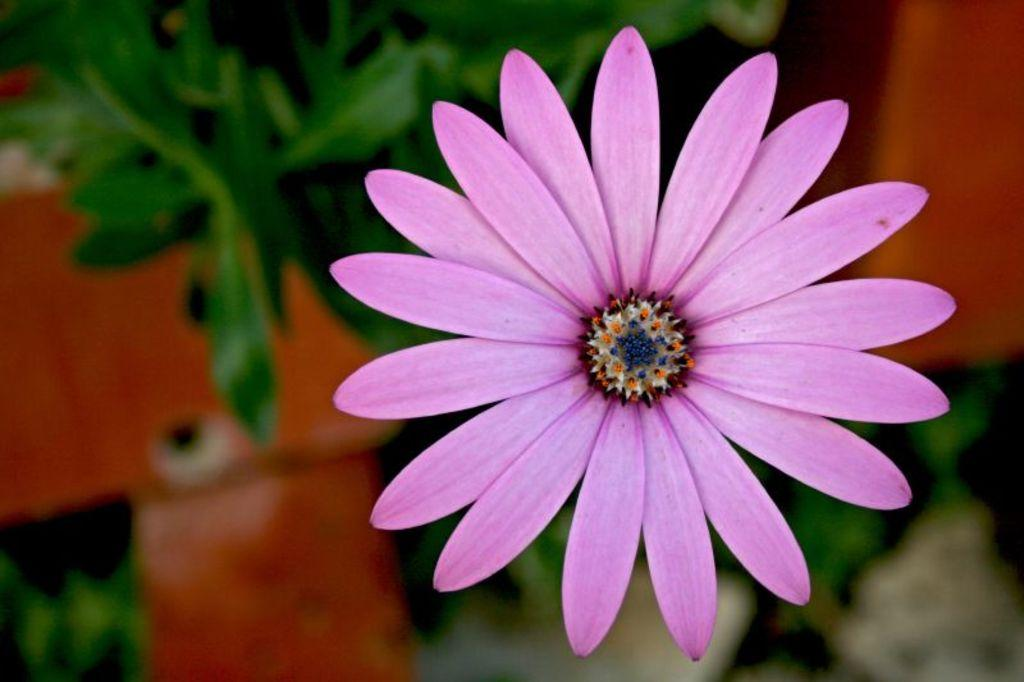What type of flower is in the image? There is a pink flower in the image. What color is the background of the image? The background of the image is green. How many pizzas are stacked on the wood in the image? There are no pizzas or wood present in the image; it features a pink flower with a green background. 